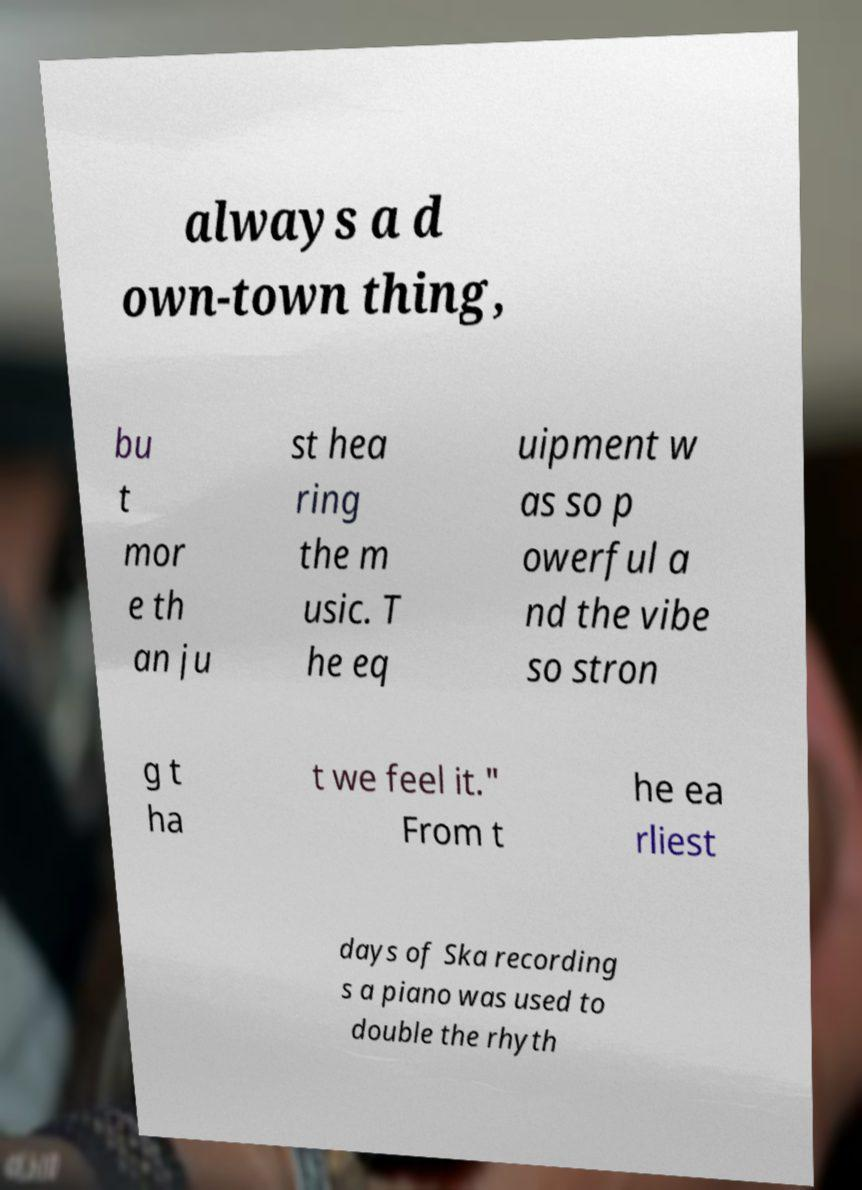Please identify and transcribe the text found in this image. always a d own-town thing, bu t mor e th an ju st hea ring the m usic. T he eq uipment w as so p owerful a nd the vibe so stron g t ha t we feel it." From t he ea rliest days of Ska recording s a piano was used to double the rhyth 